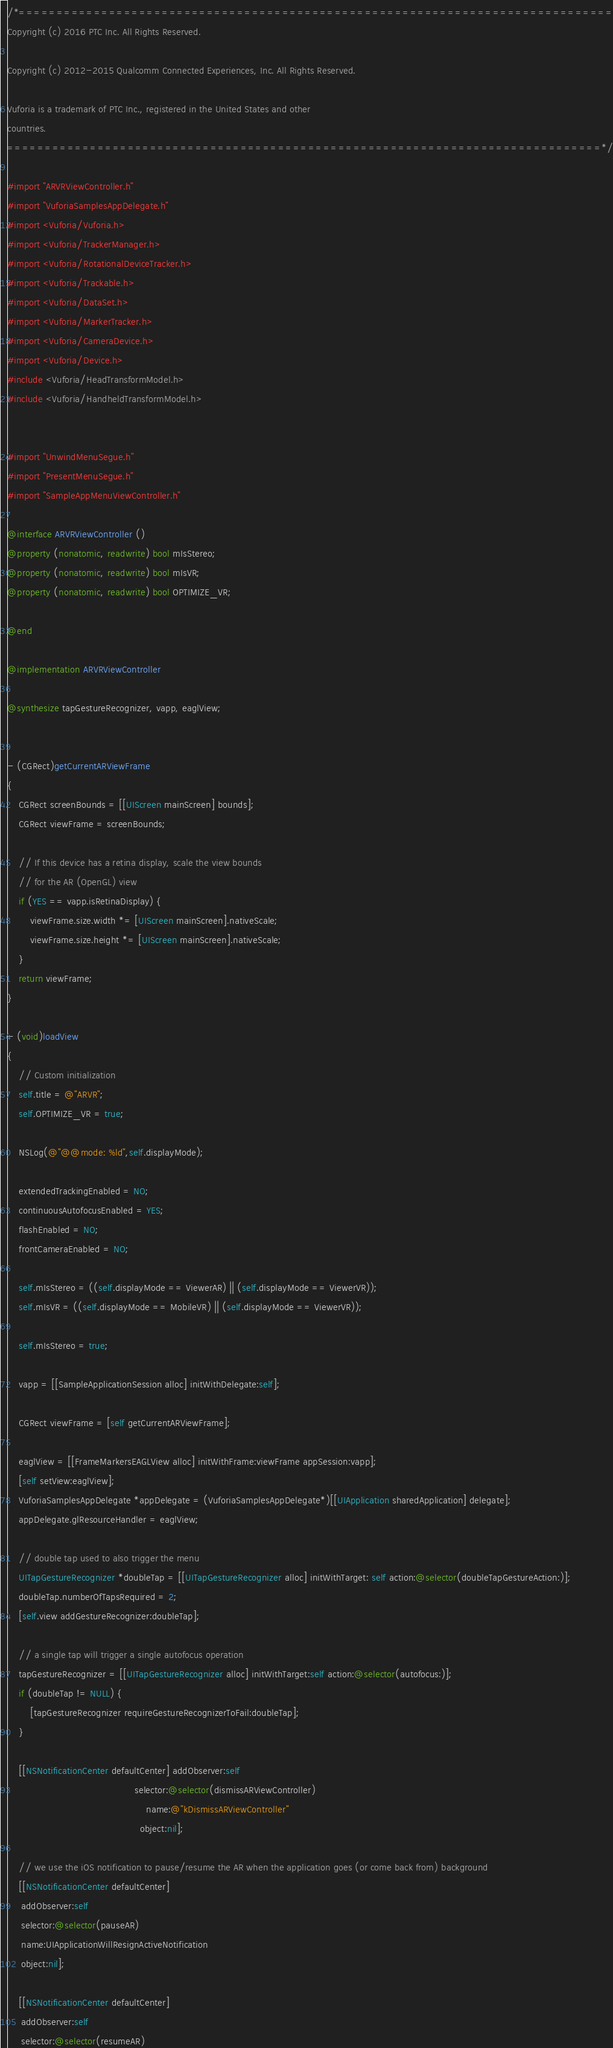<code> <loc_0><loc_0><loc_500><loc_500><_ObjectiveC_>/*===============================================================================
Copyright (c) 2016 PTC Inc. All Rights Reserved.

Copyright (c) 2012-2015 Qualcomm Connected Experiences, Inc. All Rights Reserved.

Vuforia is a trademark of PTC Inc., registered in the United States and other 
countries.
===============================================================================*/

#import "ARVRViewController.h"
#import "VuforiaSamplesAppDelegate.h"
#import <Vuforia/Vuforia.h>
#import <Vuforia/TrackerManager.h>
#import <Vuforia/RotationalDeviceTracker.h>
#import <Vuforia/Trackable.h>
#import <Vuforia/DataSet.h>
#import <Vuforia/MarkerTracker.h>
#import <Vuforia/CameraDevice.h>
#import <Vuforia/Device.h>
#include <Vuforia/HeadTransformModel.h>
#include <Vuforia/HandheldTransformModel.h>


#import "UnwindMenuSegue.h"
#import "PresentMenuSegue.h"
#import "SampleAppMenuViewController.h"

@interface ARVRViewController ()
@property (nonatomic, readwrite) bool mIsStereo;
@property (nonatomic, readwrite) bool mIsVR;
@property (nonatomic, readwrite) bool OPTIMIZE_VR;

@end

@implementation ARVRViewController

@synthesize tapGestureRecognizer, vapp, eaglView;


- (CGRect)getCurrentARViewFrame
{
    CGRect screenBounds = [[UIScreen mainScreen] bounds];
    CGRect viewFrame = screenBounds;
    
    // If this device has a retina display, scale the view bounds
    // for the AR (OpenGL) view
    if (YES == vapp.isRetinaDisplay) {
        viewFrame.size.width *= [UIScreen mainScreen].nativeScale;
        viewFrame.size.height *= [UIScreen mainScreen].nativeScale;
    }
    return viewFrame;
}

- (void)loadView
{
    // Custom initialization
    self.title = @"ARVR";
    self.OPTIMIZE_VR = true;
    
    NSLog(@"@@mode: %ld",self.displayMode);
    
    extendedTrackingEnabled = NO;
    continuousAutofocusEnabled = YES;
    flashEnabled = NO;
    frontCameraEnabled = NO;
    
    self.mIsStereo = ((self.displayMode == ViewerAR) || (self.displayMode == ViewerVR));
    self.mIsVR = ((self.displayMode == MobileVR) || (self.displayMode == ViewerVR));
    
    self.mIsStereo = true;
    
    vapp = [[SampleApplicationSession alloc] initWithDelegate:self];
    
    CGRect viewFrame = [self getCurrentARViewFrame];
    
    eaglView = [[FrameMarkersEAGLView alloc] initWithFrame:viewFrame appSession:vapp];
    [self setView:eaglView];
    VuforiaSamplesAppDelegate *appDelegate = (VuforiaSamplesAppDelegate*)[[UIApplication sharedApplication] delegate];
    appDelegate.glResourceHandler = eaglView;
    
    // double tap used to also trigger the menu
    UITapGestureRecognizer *doubleTap = [[UITapGestureRecognizer alloc] initWithTarget: self action:@selector(doubleTapGestureAction:)];
    doubleTap.numberOfTapsRequired = 2;
    [self.view addGestureRecognizer:doubleTap];
    
    // a single tap will trigger a single autofocus operation
    tapGestureRecognizer = [[UITapGestureRecognizer alloc] initWithTarget:self action:@selector(autofocus:)];
    if (doubleTap != NULL) {
        [tapGestureRecognizer requireGestureRecognizerToFail:doubleTap];
    }
    
    [[NSNotificationCenter defaultCenter] addObserver:self
                                             selector:@selector(dismissARViewController)
                                                 name:@"kDismissARViewController"
                                               object:nil];
    
    // we use the iOS notification to pause/resume the AR when the application goes (or come back from) background
    [[NSNotificationCenter defaultCenter]
     addObserver:self
     selector:@selector(pauseAR)
     name:UIApplicationWillResignActiveNotification
     object:nil];
    
    [[NSNotificationCenter defaultCenter]
     addObserver:self
     selector:@selector(resumeAR)</code> 